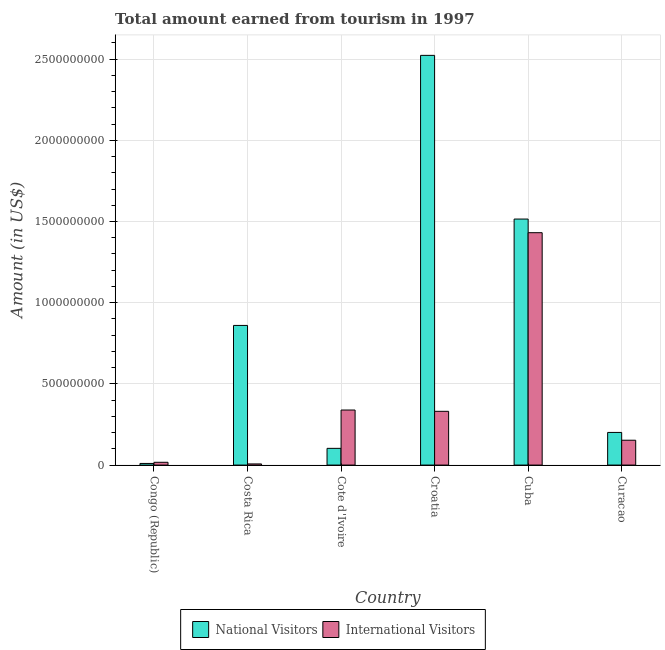How many different coloured bars are there?
Offer a terse response. 2. How many groups of bars are there?
Ensure brevity in your answer.  6. Are the number of bars on each tick of the X-axis equal?
Provide a short and direct response. Yes. How many bars are there on the 2nd tick from the left?
Provide a succinct answer. 2. How many bars are there on the 5th tick from the right?
Make the answer very short. 2. What is the label of the 6th group of bars from the left?
Provide a short and direct response. Curacao. What is the amount earned from national visitors in Croatia?
Provide a succinct answer. 2.52e+09. Across all countries, what is the maximum amount earned from national visitors?
Offer a very short reply. 2.52e+09. In which country was the amount earned from national visitors maximum?
Make the answer very short. Croatia. In which country was the amount earned from national visitors minimum?
Give a very brief answer. Congo (Republic). What is the total amount earned from international visitors in the graph?
Your response must be concise. 2.28e+09. What is the difference between the amount earned from international visitors in Congo (Republic) and that in Cuba?
Make the answer very short. -1.41e+09. What is the difference between the amount earned from international visitors in Costa Rica and the amount earned from national visitors in Cote d'Ivoire?
Your answer should be compact. -9.60e+07. What is the average amount earned from international visitors per country?
Your answer should be compact. 3.80e+08. What is the difference between the amount earned from international visitors and amount earned from national visitors in Croatia?
Give a very brief answer. -2.19e+09. What is the ratio of the amount earned from national visitors in Cote d'Ivoire to that in Curacao?
Keep it short and to the point. 0.51. Is the amount earned from international visitors in Cuba less than that in Curacao?
Provide a succinct answer. No. What is the difference between the highest and the second highest amount earned from national visitors?
Offer a terse response. 1.01e+09. What is the difference between the highest and the lowest amount earned from international visitors?
Your response must be concise. 1.42e+09. In how many countries, is the amount earned from international visitors greater than the average amount earned from international visitors taken over all countries?
Provide a succinct answer. 1. What does the 2nd bar from the left in Cote d'Ivoire represents?
Provide a short and direct response. International Visitors. What does the 1st bar from the right in Cote d'Ivoire represents?
Provide a succinct answer. International Visitors. Does the graph contain any zero values?
Ensure brevity in your answer.  No. Does the graph contain grids?
Keep it short and to the point. Yes. What is the title of the graph?
Keep it short and to the point. Total amount earned from tourism in 1997. Does "From World Bank" appear as one of the legend labels in the graph?
Your response must be concise. No. What is the label or title of the X-axis?
Your answer should be very brief. Country. What is the Amount (in US$) of National Visitors in Congo (Republic)?
Provide a short and direct response. 1.00e+07. What is the Amount (in US$) of International Visitors in Congo (Republic)?
Ensure brevity in your answer.  1.71e+07. What is the Amount (in US$) in National Visitors in Costa Rica?
Your answer should be compact. 8.60e+08. What is the Amount (in US$) of National Visitors in Cote d'Ivoire?
Give a very brief answer. 1.03e+08. What is the Amount (in US$) of International Visitors in Cote d'Ivoire?
Your response must be concise. 3.39e+08. What is the Amount (in US$) of National Visitors in Croatia?
Ensure brevity in your answer.  2.52e+09. What is the Amount (in US$) in International Visitors in Croatia?
Make the answer very short. 3.31e+08. What is the Amount (in US$) of National Visitors in Cuba?
Offer a very short reply. 1.52e+09. What is the Amount (in US$) in International Visitors in Cuba?
Your response must be concise. 1.43e+09. What is the Amount (in US$) of National Visitors in Curacao?
Your answer should be compact. 2.01e+08. What is the Amount (in US$) of International Visitors in Curacao?
Offer a very short reply. 1.53e+08. Across all countries, what is the maximum Amount (in US$) in National Visitors?
Provide a short and direct response. 2.52e+09. Across all countries, what is the maximum Amount (in US$) in International Visitors?
Provide a short and direct response. 1.43e+09. Across all countries, what is the minimum Amount (in US$) in International Visitors?
Ensure brevity in your answer.  7.00e+06. What is the total Amount (in US$) of National Visitors in the graph?
Offer a terse response. 5.21e+09. What is the total Amount (in US$) of International Visitors in the graph?
Make the answer very short. 2.28e+09. What is the difference between the Amount (in US$) of National Visitors in Congo (Republic) and that in Costa Rica?
Provide a succinct answer. -8.50e+08. What is the difference between the Amount (in US$) in International Visitors in Congo (Republic) and that in Costa Rica?
Provide a short and direct response. 1.01e+07. What is the difference between the Amount (in US$) in National Visitors in Congo (Republic) and that in Cote d'Ivoire?
Ensure brevity in your answer.  -9.30e+07. What is the difference between the Amount (in US$) in International Visitors in Congo (Republic) and that in Cote d'Ivoire?
Offer a very short reply. -3.22e+08. What is the difference between the Amount (in US$) of National Visitors in Congo (Republic) and that in Croatia?
Give a very brief answer. -2.51e+09. What is the difference between the Amount (in US$) in International Visitors in Congo (Republic) and that in Croatia?
Keep it short and to the point. -3.14e+08. What is the difference between the Amount (in US$) in National Visitors in Congo (Republic) and that in Cuba?
Offer a terse response. -1.50e+09. What is the difference between the Amount (in US$) of International Visitors in Congo (Republic) and that in Cuba?
Give a very brief answer. -1.41e+09. What is the difference between the Amount (in US$) of National Visitors in Congo (Republic) and that in Curacao?
Offer a very short reply. -1.91e+08. What is the difference between the Amount (in US$) of International Visitors in Congo (Republic) and that in Curacao?
Your answer should be compact. -1.36e+08. What is the difference between the Amount (in US$) of National Visitors in Costa Rica and that in Cote d'Ivoire?
Provide a succinct answer. 7.57e+08. What is the difference between the Amount (in US$) of International Visitors in Costa Rica and that in Cote d'Ivoire?
Ensure brevity in your answer.  -3.32e+08. What is the difference between the Amount (in US$) of National Visitors in Costa Rica and that in Croatia?
Your answer should be very brief. -1.66e+09. What is the difference between the Amount (in US$) of International Visitors in Costa Rica and that in Croatia?
Offer a terse response. -3.24e+08. What is the difference between the Amount (in US$) in National Visitors in Costa Rica and that in Cuba?
Your answer should be compact. -6.55e+08. What is the difference between the Amount (in US$) of International Visitors in Costa Rica and that in Cuba?
Your response must be concise. -1.42e+09. What is the difference between the Amount (in US$) of National Visitors in Costa Rica and that in Curacao?
Keep it short and to the point. 6.59e+08. What is the difference between the Amount (in US$) in International Visitors in Costa Rica and that in Curacao?
Your answer should be very brief. -1.46e+08. What is the difference between the Amount (in US$) of National Visitors in Cote d'Ivoire and that in Croatia?
Offer a terse response. -2.42e+09. What is the difference between the Amount (in US$) of International Visitors in Cote d'Ivoire and that in Croatia?
Keep it short and to the point. 8.00e+06. What is the difference between the Amount (in US$) in National Visitors in Cote d'Ivoire and that in Cuba?
Make the answer very short. -1.41e+09. What is the difference between the Amount (in US$) of International Visitors in Cote d'Ivoire and that in Cuba?
Give a very brief answer. -1.09e+09. What is the difference between the Amount (in US$) in National Visitors in Cote d'Ivoire and that in Curacao?
Provide a succinct answer. -9.80e+07. What is the difference between the Amount (in US$) in International Visitors in Cote d'Ivoire and that in Curacao?
Make the answer very short. 1.86e+08. What is the difference between the Amount (in US$) in National Visitors in Croatia and that in Cuba?
Keep it short and to the point. 1.01e+09. What is the difference between the Amount (in US$) in International Visitors in Croatia and that in Cuba?
Offer a very short reply. -1.10e+09. What is the difference between the Amount (in US$) in National Visitors in Croatia and that in Curacao?
Provide a succinct answer. 2.32e+09. What is the difference between the Amount (in US$) of International Visitors in Croatia and that in Curacao?
Give a very brief answer. 1.78e+08. What is the difference between the Amount (in US$) in National Visitors in Cuba and that in Curacao?
Provide a short and direct response. 1.31e+09. What is the difference between the Amount (in US$) of International Visitors in Cuba and that in Curacao?
Make the answer very short. 1.28e+09. What is the difference between the Amount (in US$) of National Visitors in Congo (Republic) and the Amount (in US$) of International Visitors in Cote d'Ivoire?
Provide a short and direct response. -3.29e+08. What is the difference between the Amount (in US$) of National Visitors in Congo (Republic) and the Amount (in US$) of International Visitors in Croatia?
Keep it short and to the point. -3.21e+08. What is the difference between the Amount (in US$) in National Visitors in Congo (Republic) and the Amount (in US$) in International Visitors in Cuba?
Your response must be concise. -1.42e+09. What is the difference between the Amount (in US$) in National Visitors in Congo (Republic) and the Amount (in US$) in International Visitors in Curacao?
Keep it short and to the point. -1.43e+08. What is the difference between the Amount (in US$) in National Visitors in Costa Rica and the Amount (in US$) in International Visitors in Cote d'Ivoire?
Your response must be concise. 5.21e+08. What is the difference between the Amount (in US$) in National Visitors in Costa Rica and the Amount (in US$) in International Visitors in Croatia?
Ensure brevity in your answer.  5.29e+08. What is the difference between the Amount (in US$) in National Visitors in Costa Rica and the Amount (in US$) in International Visitors in Cuba?
Offer a very short reply. -5.71e+08. What is the difference between the Amount (in US$) of National Visitors in Costa Rica and the Amount (in US$) of International Visitors in Curacao?
Provide a short and direct response. 7.07e+08. What is the difference between the Amount (in US$) in National Visitors in Cote d'Ivoire and the Amount (in US$) in International Visitors in Croatia?
Provide a short and direct response. -2.28e+08. What is the difference between the Amount (in US$) of National Visitors in Cote d'Ivoire and the Amount (in US$) of International Visitors in Cuba?
Ensure brevity in your answer.  -1.33e+09. What is the difference between the Amount (in US$) in National Visitors in Cote d'Ivoire and the Amount (in US$) in International Visitors in Curacao?
Keep it short and to the point. -5.00e+07. What is the difference between the Amount (in US$) of National Visitors in Croatia and the Amount (in US$) of International Visitors in Cuba?
Offer a terse response. 1.09e+09. What is the difference between the Amount (in US$) of National Visitors in Croatia and the Amount (in US$) of International Visitors in Curacao?
Ensure brevity in your answer.  2.37e+09. What is the difference between the Amount (in US$) in National Visitors in Cuba and the Amount (in US$) in International Visitors in Curacao?
Give a very brief answer. 1.36e+09. What is the average Amount (in US$) of National Visitors per country?
Keep it short and to the point. 8.69e+08. What is the average Amount (in US$) of International Visitors per country?
Offer a very short reply. 3.80e+08. What is the difference between the Amount (in US$) in National Visitors and Amount (in US$) in International Visitors in Congo (Republic)?
Your answer should be compact. -7.10e+06. What is the difference between the Amount (in US$) in National Visitors and Amount (in US$) in International Visitors in Costa Rica?
Give a very brief answer. 8.53e+08. What is the difference between the Amount (in US$) in National Visitors and Amount (in US$) in International Visitors in Cote d'Ivoire?
Your answer should be compact. -2.36e+08. What is the difference between the Amount (in US$) of National Visitors and Amount (in US$) of International Visitors in Croatia?
Give a very brief answer. 2.19e+09. What is the difference between the Amount (in US$) in National Visitors and Amount (in US$) in International Visitors in Cuba?
Provide a succinct answer. 8.40e+07. What is the difference between the Amount (in US$) in National Visitors and Amount (in US$) in International Visitors in Curacao?
Provide a succinct answer. 4.80e+07. What is the ratio of the Amount (in US$) of National Visitors in Congo (Republic) to that in Costa Rica?
Your answer should be compact. 0.01. What is the ratio of the Amount (in US$) in International Visitors in Congo (Republic) to that in Costa Rica?
Ensure brevity in your answer.  2.44. What is the ratio of the Amount (in US$) of National Visitors in Congo (Republic) to that in Cote d'Ivoire?
Your response must be concise. 0.1. What is the ratio of the Amount (in US$) in International Visitors in Congo (Republic) to that in Cote d'Ivoire?
Your answer should be compact. 0.05. What is the ratio of the Amount (in US$) in National Visitors in Congo (Republic) to that in Croatia?
Offer a very short reply. 0. What is the ratio of the Amount (in US$) in International Visitors in Congo (Republic) to that in Croatia?
Provide a short and direct response. 0.05. What is the ratio of the Amount (in US$) of National Visitors in Congo (Republic) to that in Cuba?
Provide a short and direct response. 0.01. What is the ratio of the Amount (in US$) of International Visitors in Congo (Republic) to that in Cuba?
Keep it short and to the point. 0.01. What is the ratio of the Amount (in US$) of National Visitors in Congo (Republic) to that in Curacao?
Your answer should be very brief. 0.05. What is the ratio of the Amount (in US$) in International Visitors in Congo (Republic) to that in Curacao?
Offer a very short reply. 0.11. What is the ratio of the Amount (in US$) of National Visitors in Costa Rica to that in Cote d'Ivoire?
Your answer should be very brief. 8.35. What is the ratio of the Amount (in US$) in International Visitors in Costa Rica to that in Cote d'Ivoire?
Your response must be concise. 0.02. What is the ratio of the Amount (in US$) of National Visitors in Costa Rica to that in Croatia?
Your answer should be compact. 0.34. What is the ratio of the Amount (in US$) of International Visitors in Costa Rica to that in Croatia?
Keep it short and to the point. 0.02. What is the ratio of the Amount (in US$) in National Visitors in Costa Rica to that in Cuba?
Make the answer very short. 0.57. What is the ratio of the Amount (in US$) in International Visitors in Costa Rica to that in Cuba?
Offer a terse response. 0. What is the ratio of the Amount (in US$) of National Visitors in Costa Rica to that in Curacao?
Make the answer very short. 4.28. What is the ratio of the Amount (in US$) of International Visitors in Costa Rica to that in Curacao?
Your response must be concise. 0.05. What is the ratio of the Amount (in US$) of National Visitors in Cote d'Ivoire to that in Croatia?
Keep it short and to the point. 0.04. What is the ratio of the Amount (in US$) in International Visitors in Cote d'Ivoire to that in Croatia?
Make the answer very short. 1.02. What is the ratio of the Amount (in US$) in National Visitors in Cote d'Ivoire to that in Cuba?
Offer a very short reply. 0.07. What is the ratio of the Amount (in US$) in International Visitors in Cote d'Ivoire to that in Cuba?
Provide a short and direct response. 0.24. What is the ratio of the Amount (in US$) of National Visitors in Cote d'Ivoire to that in Curacao?
Your answer should be compact. 0.51. What is the ratio of the Amount (in US$) of International Visitors in Cote d'Ivoire to that in Curacao?
Ensure brevity in your answer.  2.22. What is the ratio of the Amount (in US$) in National Visitors in Croatia to that in Cuba?
Your response must be concise. 1.67. What is the ratio of the Amount (in US$) in International Visitors in Croatia to that in Cuba?
Make the answer very short. 0.23. What is the ratio of the Amount (in US$) of National Visitors in Croatia to that in Curacao?
Offer a terse response. 12.55. What is the ratio of the Amount (in US$) in International Visitors in Croatia to that in Curacao?
Provide a succinct answer. 2.16. What is the ratio of the Amount (in US$) in National Visitors in Cuba to that in Curacao?
Your answer should be very brief. 7.54. What is the ratio of the Amount (in US$) in International Visitors in Cuba to that in Curacao?
Your answer should be compact. 9.35. What is the difference between the highest and the second highest Amount (in US$) in National Visitors?
Your answer should be compact. 1.01e+09. What is the difference between the highest and the second highest Amount (in US$) in International Visitors?
Keep it short and to the point. 1.09e+09. What is the difference between the highest and the lowest Amount (in US$) of National Visitors?
Make the answer very short. 2.51e+09. What is the difference between the highest and the lowest Amount (in US$) of International Visitors?
Provide a succinct answer. 1.42e+09. 